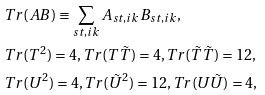Convert formula to latex. <formula><loc_0><loc_0><loc_500><loc_500>& T r ( A B ) \equiv \sum _ { s t , i k } A _ { s t , i k } B _ { s t , i k } , \\ & T r ( T ^ { 2 } ) = 4 , T r ( T \tilde { T } ) = 4 , T r ( \tilde { T } \tilde { T } ) = 1 2 , \\ & T r ( U ^ { 2 } ) = 4 , T r ( \tilde { U } ^ { 2 } ) = 1 2 , T r ( U \tilde { U } ) = 4 ,</formula> 